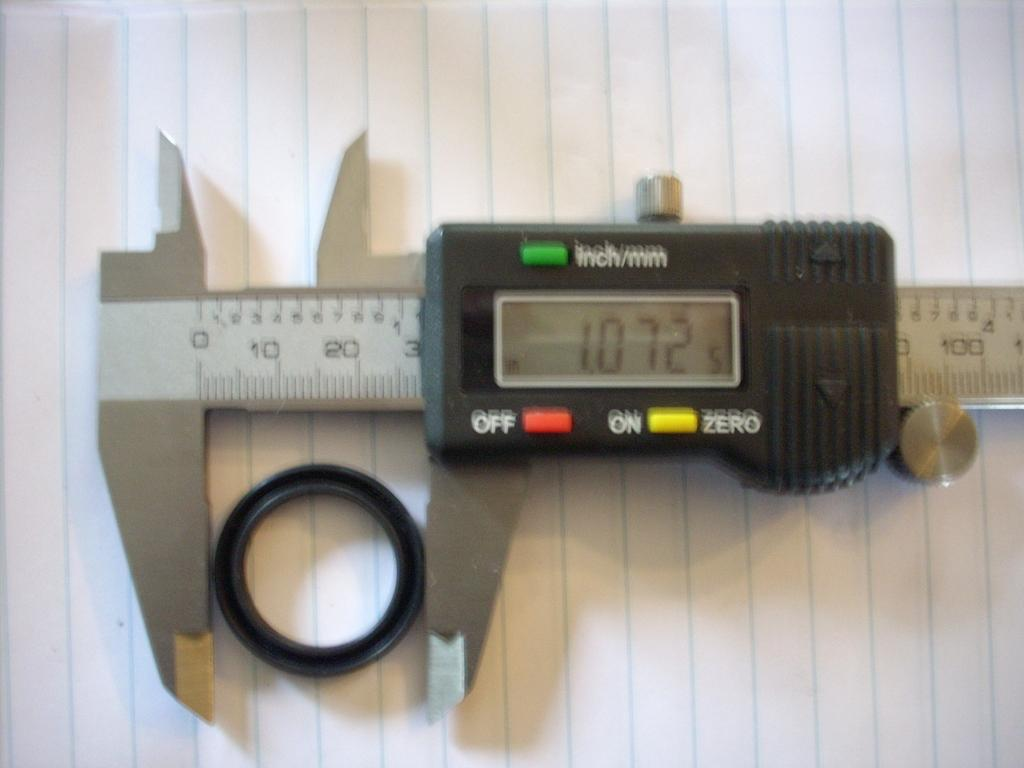What is the main tool visible in the image? There is a digital caliper in the image. What is the caliper measuring or inspecting in the image? The image shows the caliper measuring or inspecting an object on a paper. What type of spark can be seen coming from the digital caliper in the image? There is no spark visible in the image; the digital caliper is simply measuring or inspecting an object on a paper. 